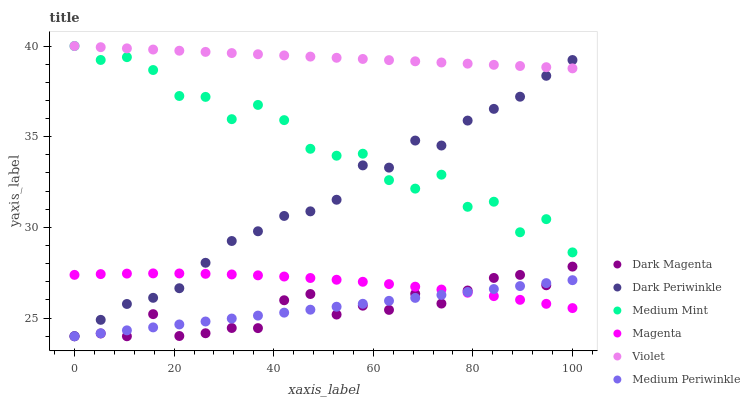Does Dark Magenta have the minimum area under the curve?
Answer yes or no. Yes. Does Violet have the maximum area under the curve?
Answer yes or no. Yes. Does Medium Periwinkle have the minimum area under the curve?
Answer yes or no. No. Does Medium Periwinkle have the maximum area under the curve?
Answer yes or no. No. Is Medium Periwinkle the smoothest?
Answer yes or no. Yes. Is Medium Mint the roughest?
Answer yes or no. Yes. Is Dark Magenta the smoothest?
Answer yes or no. No. Is Dark Magenta the roughest?
Answer yes or no. No. Does Dark Magenta have the lowest value?
Answer yes or no. Yes. Does Violet have the lowest value?
Answer yes or no. No. Does Violet have the highest value?
Answer yes or no. Yes. Does Dark Magenta have the highest value?
Answer yes or no. No. Is Magenta less than Violet?
Answer yes or no. Yes. Is Violet greater than Dark Magenta?
Answer yes or no. Yes. Does Dark Periwinkle intersect Magenta?
Answer yes or no. Yes. Is Dark Periwinkle less than Magenta?
Answer yes or no. No. Is Dark Periwinkle greater than Magenta?
Answer yes or no. No. Does Magenta intersect Violet?
Answer yes or no. No. 